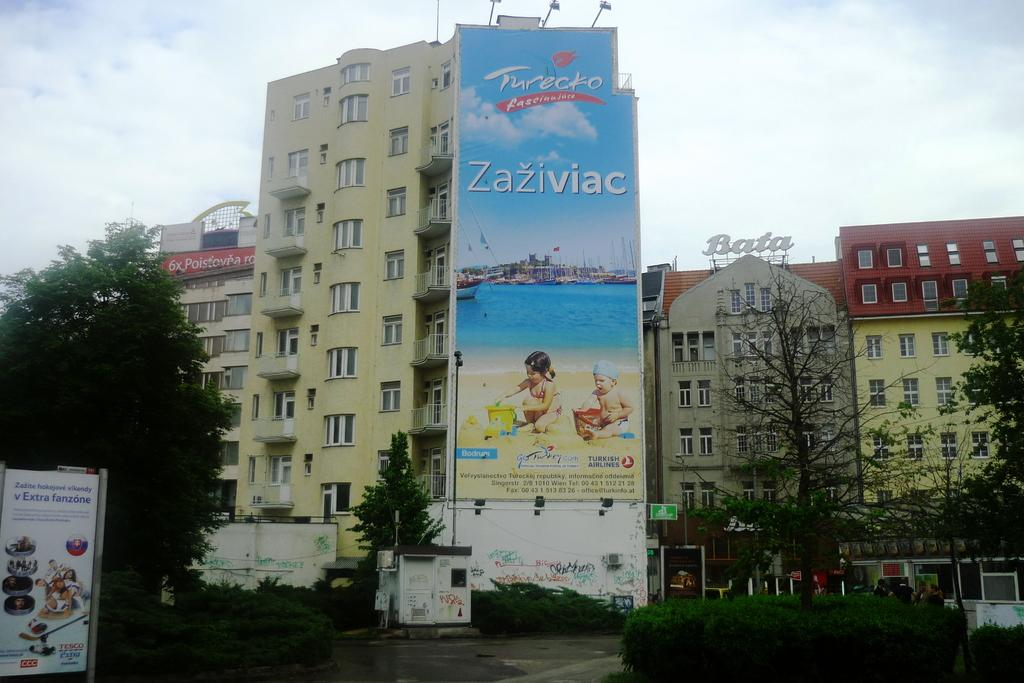<image>
Present a compact description of the photo's key features. A building with a large poster for Zaziviac on the wall. 